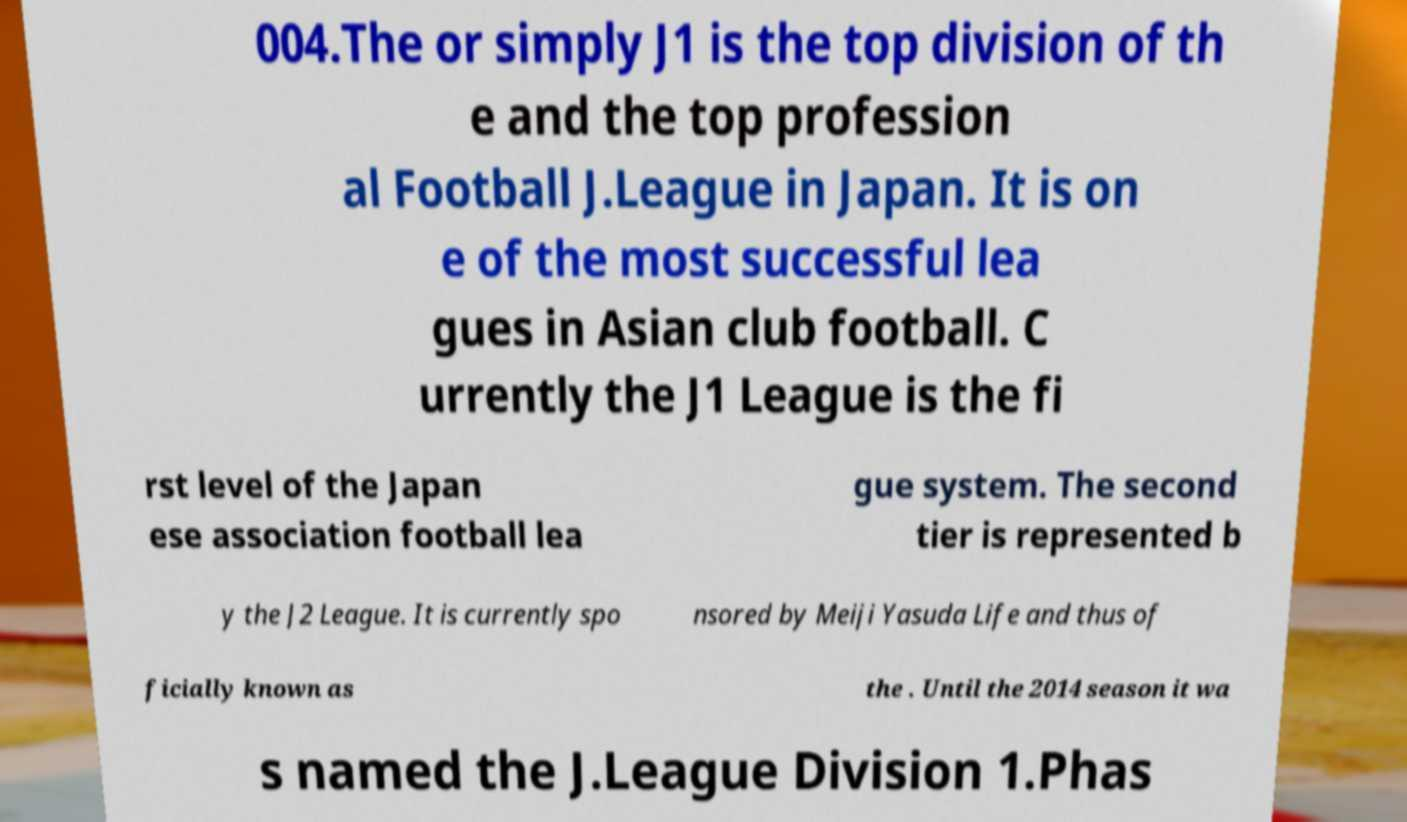Could you assist in decoding the text presented in this image and type it out clearly? 004.The or simply J1 is the top division of th e and the top profession al Football J.League in Japan. It is on e of the most successful lea gues in Asian club football. C urrently the J1 League is the fi rst level of the Japan ese association football lea gue system. The second tier is represented b y the J2 League. It is currently spo nsored by Meiji Yasuda Life and thus of ficially known as the . Until the 2014 season it wa s named the J.League Division 1.Phas 